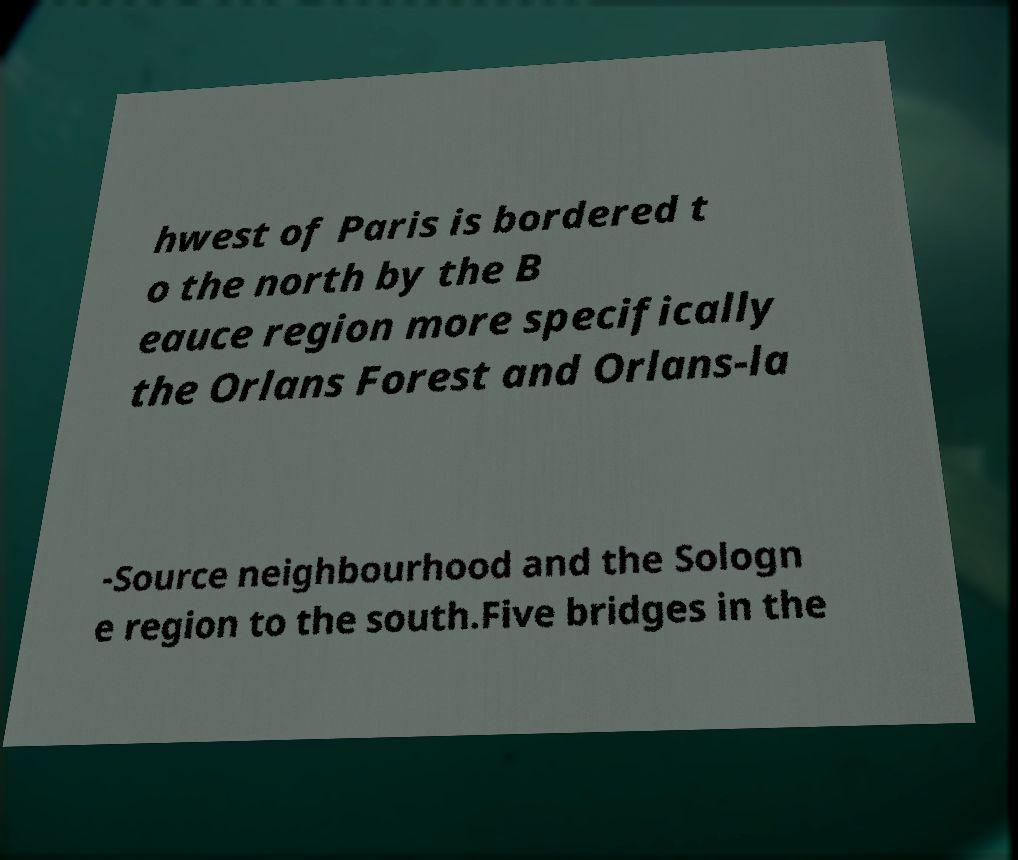For documentation purposes, I need the text within this image transcribed. Could you provide that? hwest of Paris is bordered t o the north by the B eauce region more specifically the Orlans Forest and Orlans-la -Source neighbourhood and the Sologn e region to the south.Five bridges in the 